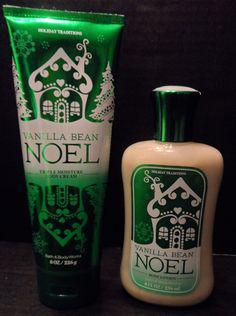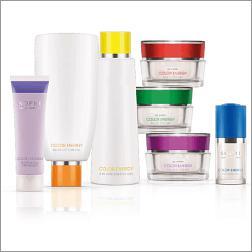The first image is the image on the left, the second image is the image on the right. Given the left and right images, does the statement "An image contains only two side-by-side products, which feature green in the packaging." hold true? Answer yes or no. Yes. The first image is the image on the left, the second image is the image on the right. Given the left and right images, does the statement "Two containers stand together in the image on the left." hold true? Answer yes or no. Yes. 